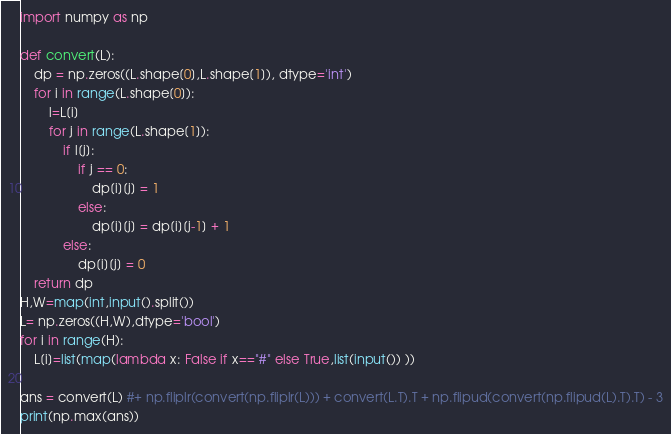Convert code to text. <code><loc_0><loc_0><loc_500><loc_500><_Python_>import numpy as np
 
def convert(L):
    dp = np.zeros((L.shape[0],L.shape[1]), dtype='int')
    for i in range(L.shape[0]):
        l=L[i]
        for j in range(L.shape[1]):
            if l[j]:
                if j == 0:
                    dp[i][j] = 1
                else:
                    dp[i][j] = dp[i][j-1] + 1
            else:
                dp[i][j] = 0
    return dp
H,W=map(int,input().split())
L= np.zeros((H,W),dtype='bool')
for i in range(H):
    L[i]=list(map(lambda x: False if x=="#" else True,list(input()) ))
 
ans = convert(L) #+ np.fliplr(convert(np.fliplr(L))) + convert(L.T).T + np.flipud(convert(np.flipud(L).T).T) - 3
print(np.max(ans))</code> 